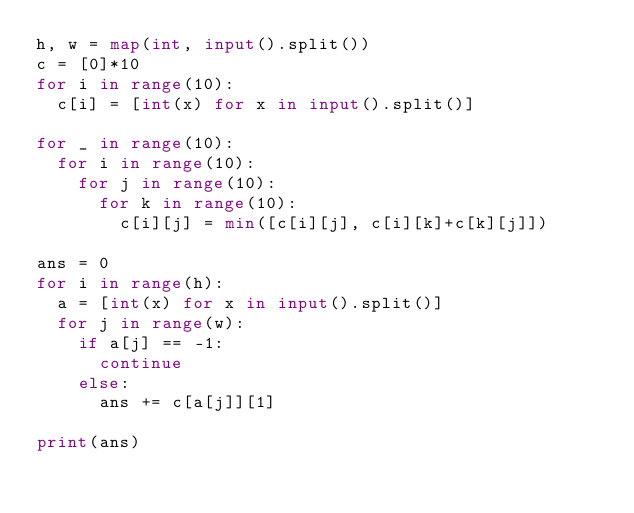Convert code to text. <code><loc_0><loc_0><loc_500><loc_500><_Python_>h, w = map(int, input().split())
c = [0]*10
for i in range(10):
  c[i] = [int(x) for x in input().split()]

for _ in range(10):
  for i in range(10):
    for j in range(10):
      for k in range(10):
        c[i][j] = min([c[i][j], c[i][k]+c[k][j]])

ans = 0
for i in range(h):
  a = [int(x) for x in input().split()]
  for j in range(w):
    if a[j] == -1:
      continue
    else:
      ans += c[a[j]][1]

print(ans)</code> 